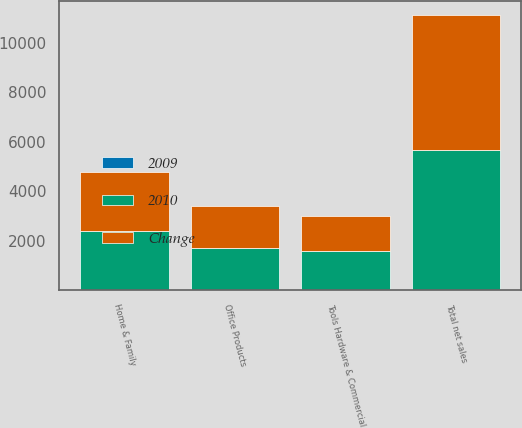<chart> <loc_0><loc_0><loc_500><loc_500><stacked_bar_chart><ecel><fcel>Home & Family<fcel>Office Products<fcel>Tools Hardware & Commercial<fcel>Total net sales<nl><fcel>2010<fcel>2378.4<fcel>1708.9<fcel>1570.9<fcel>5658.2<nl><fcel>Change<fcel>2377.2<fcel>1674.7<fcel>1431.5<fcel>5483.4<nl><fcel>2009<fcel>0.1<fcel>2<fcel>9.7<fcel>3.2<nl></chart> 